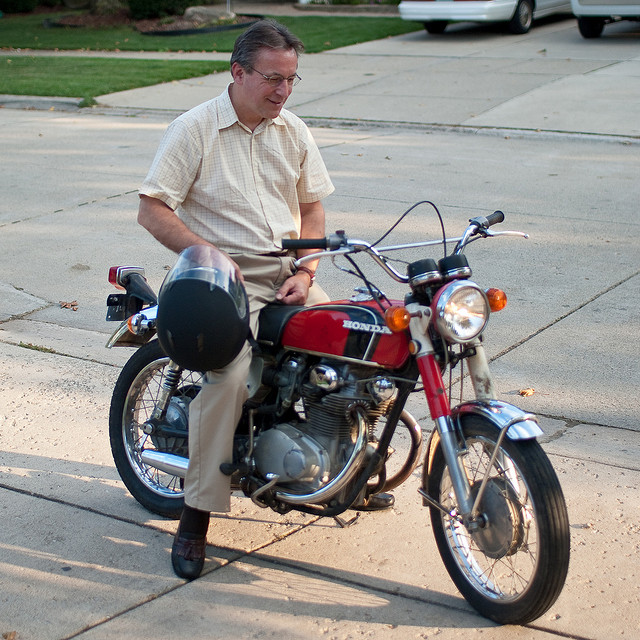Extract all visible text content from this image. HONDA 